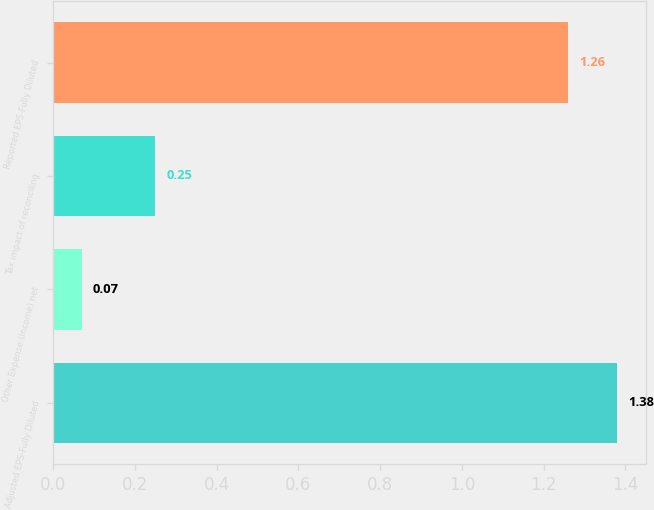Convert chart. <chart><loc_0><loc_0><loc_500><loc_500><bar_chart><fcel>Adjusted EPS-Fully Diluted<fcel>Other Expense (Income) net<fcel>Tax impact of reconciling<fcel>Reported EPS-Fully Diluted<nl><fcel>1.38<fcel>0.07<fcel>0.25<fcel>1.26<nl></chart> 